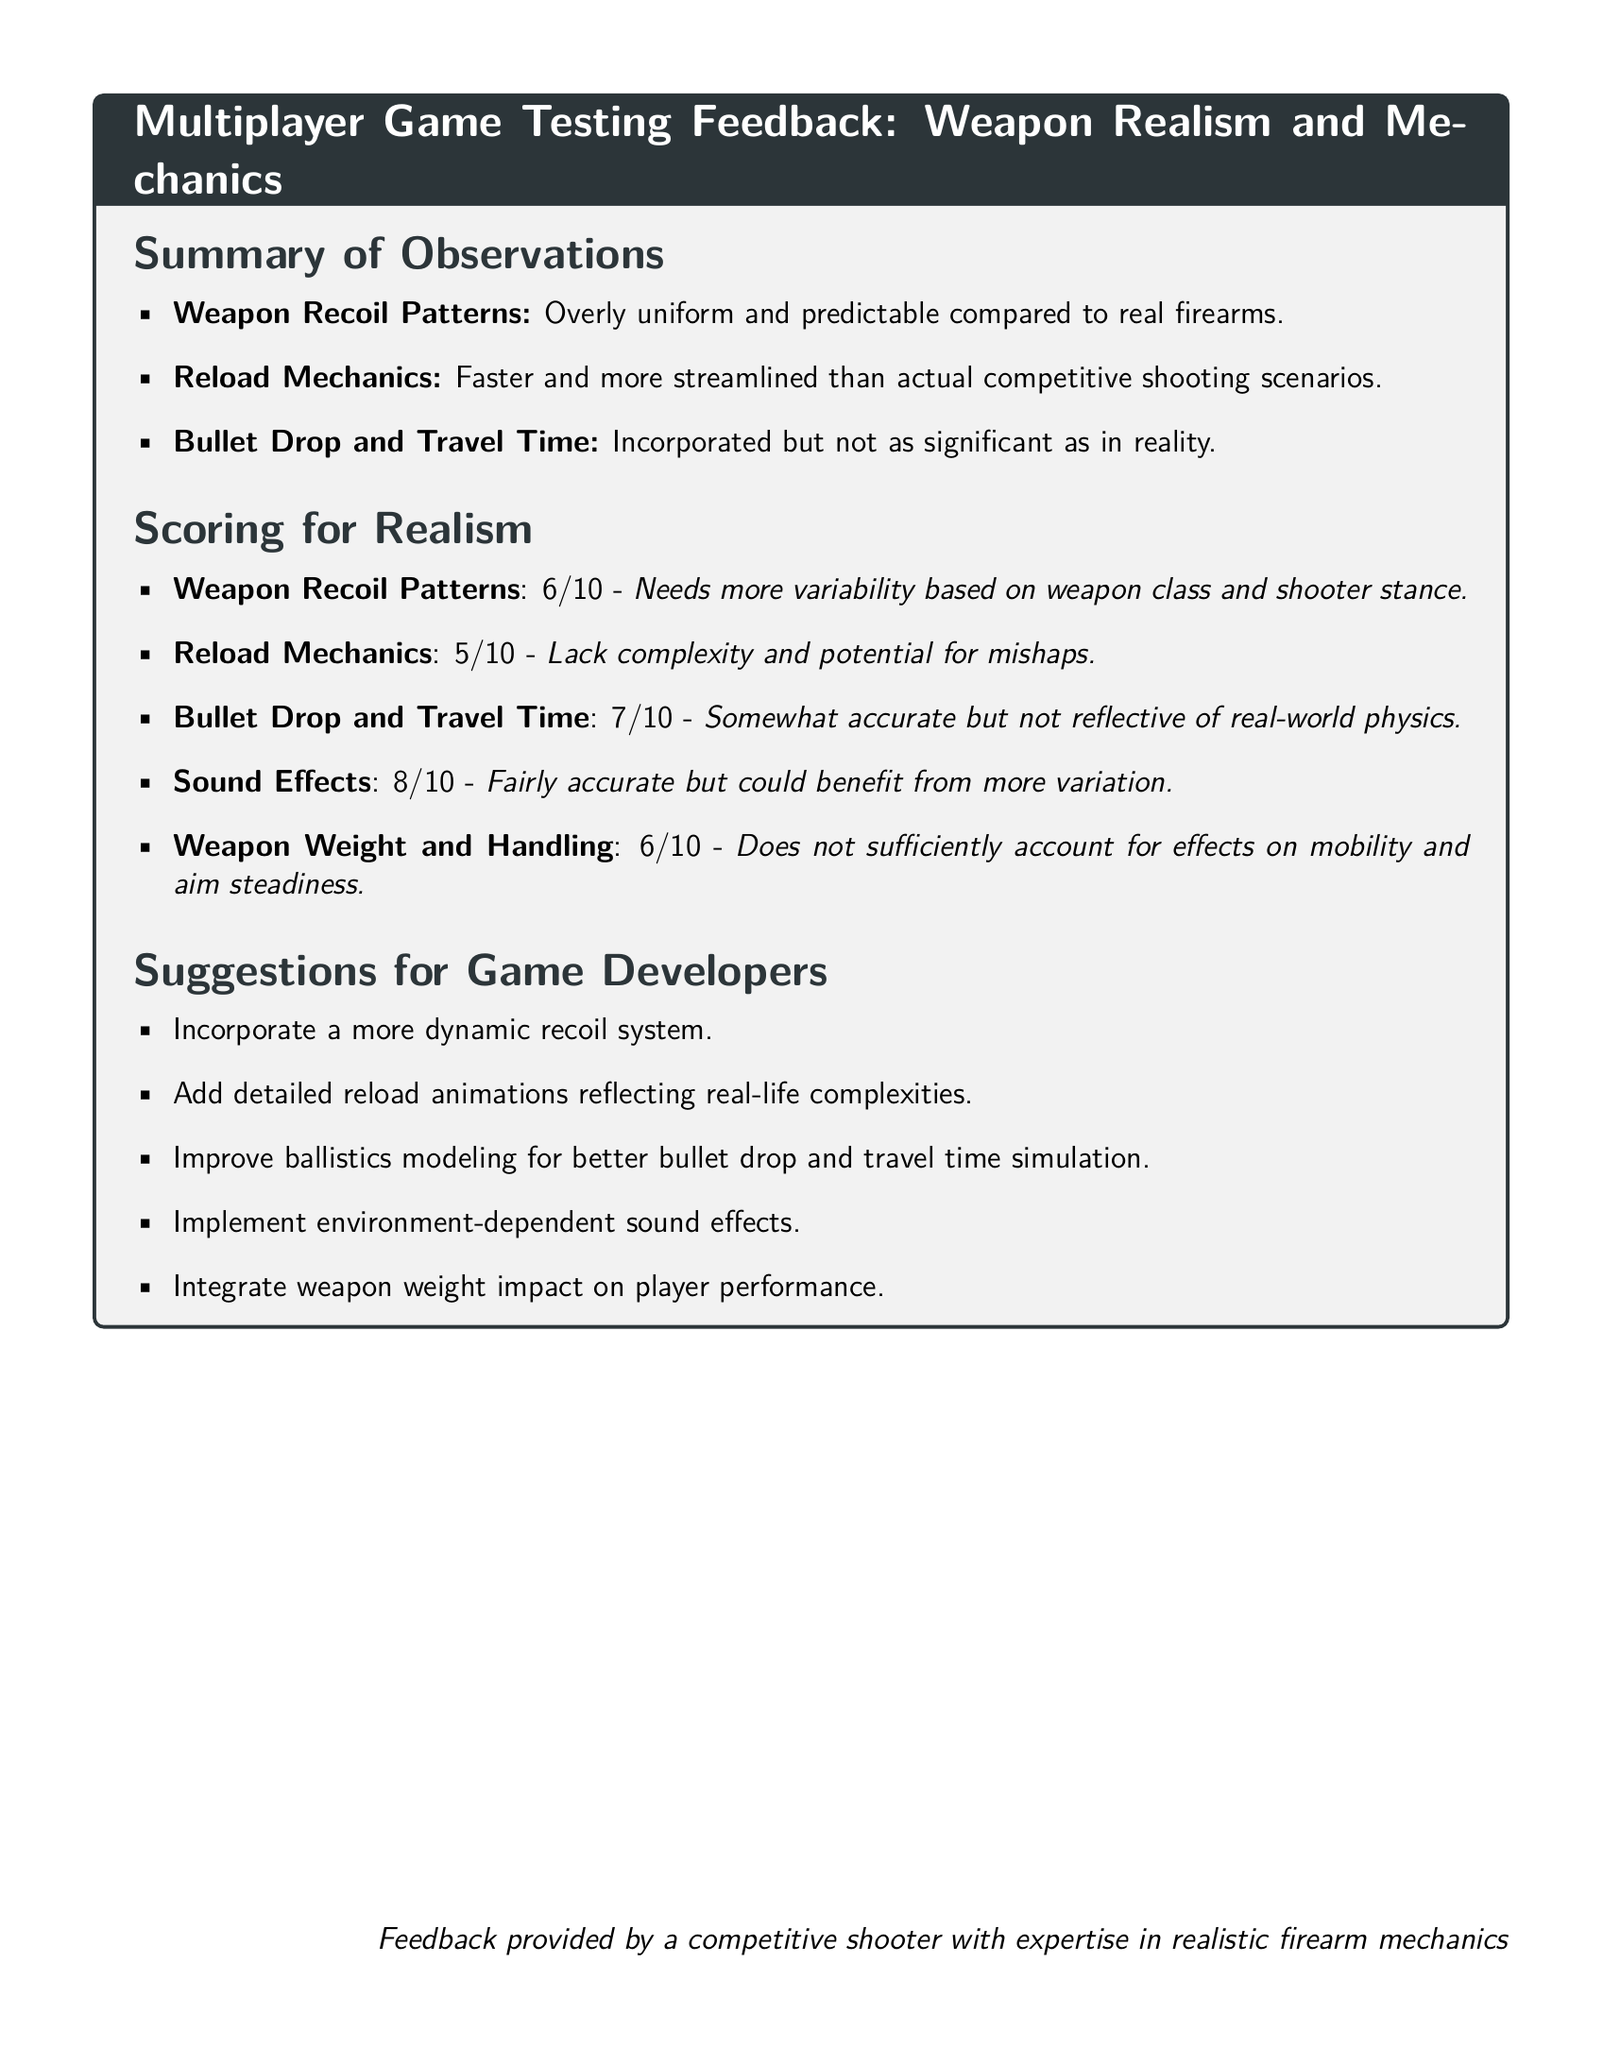What is the score for Weapon Recoil Patterns? The score for Weapon Recoil Patterns is 6, as stated in the Scoring for Realism section.
Answer: 6 What is one suggestion for game developers regarding reload mechanics? One suggestion provided is to add detailed reload animations reflecting real-life complexities.
Answer: Add detailed reload animations What was the scoring for Bullet Drop and Travel Time? The scoring for Bullet Drop and Travel Time is 7, which indicates its accuracy is somewhat better but still not completely reflective of real-world physics.
Answer: 7 What aspect of sound effects was noted in the summary? The summary indicates that sound effects are fairly accurate but could benefit from more variation, highlighting the need for improvement.
Answer: More variation What is the score for Reload Mechanics? The score for Reload Mechanics is 5, reflecting its lack of complexity and potential for mishaps.
Answer: 5 What does the score of 8 represent in the document? The score of 8 represents the assessment of Sound Effects, indicating they are fairly accurate overall.
Answer: 8 How does the document describe the weapon recoil patterns? The document describes weapon recoil patterns as overly uniform and predictable compared to real firearms.
Answer: Overly uniform and predictable What is the main focus of the document? The main focus of the document is on Multiplayer Game Testing Feedback, specifically regarding Weapon Realism and Mechanics.
Answer: Weapon Realism and Mechanics What does the document suggest improving for better bullet simulation? It suggests improving ballistics modeling for better bullet drop and travel time simulation.
Answer: Improve ballistics modeling 